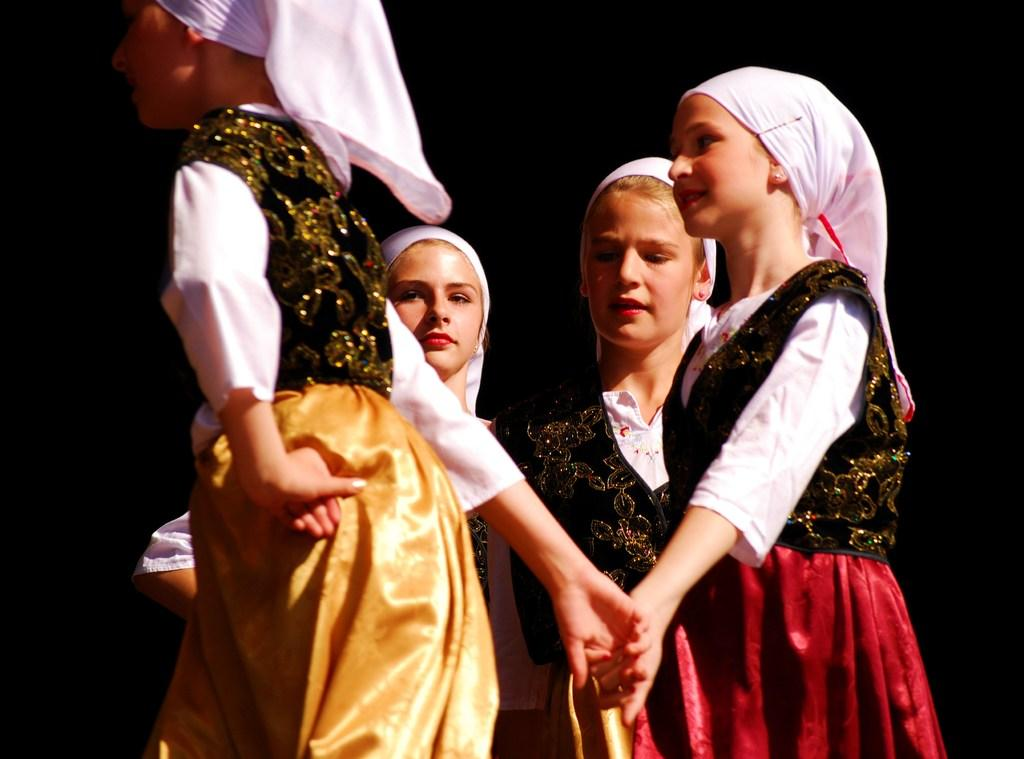How many girls are in the image? There are four girls in the image. What color are the tops that the girls are wearing? Each girl is wearing a black top. What type of accessory is the girls wearing around their necks? Each girl is wearing a white scarf. What type of straw is being used to make a pie in the image? There is no straw or pie present in the image; it features four girls wearing black tops and white scarves. 